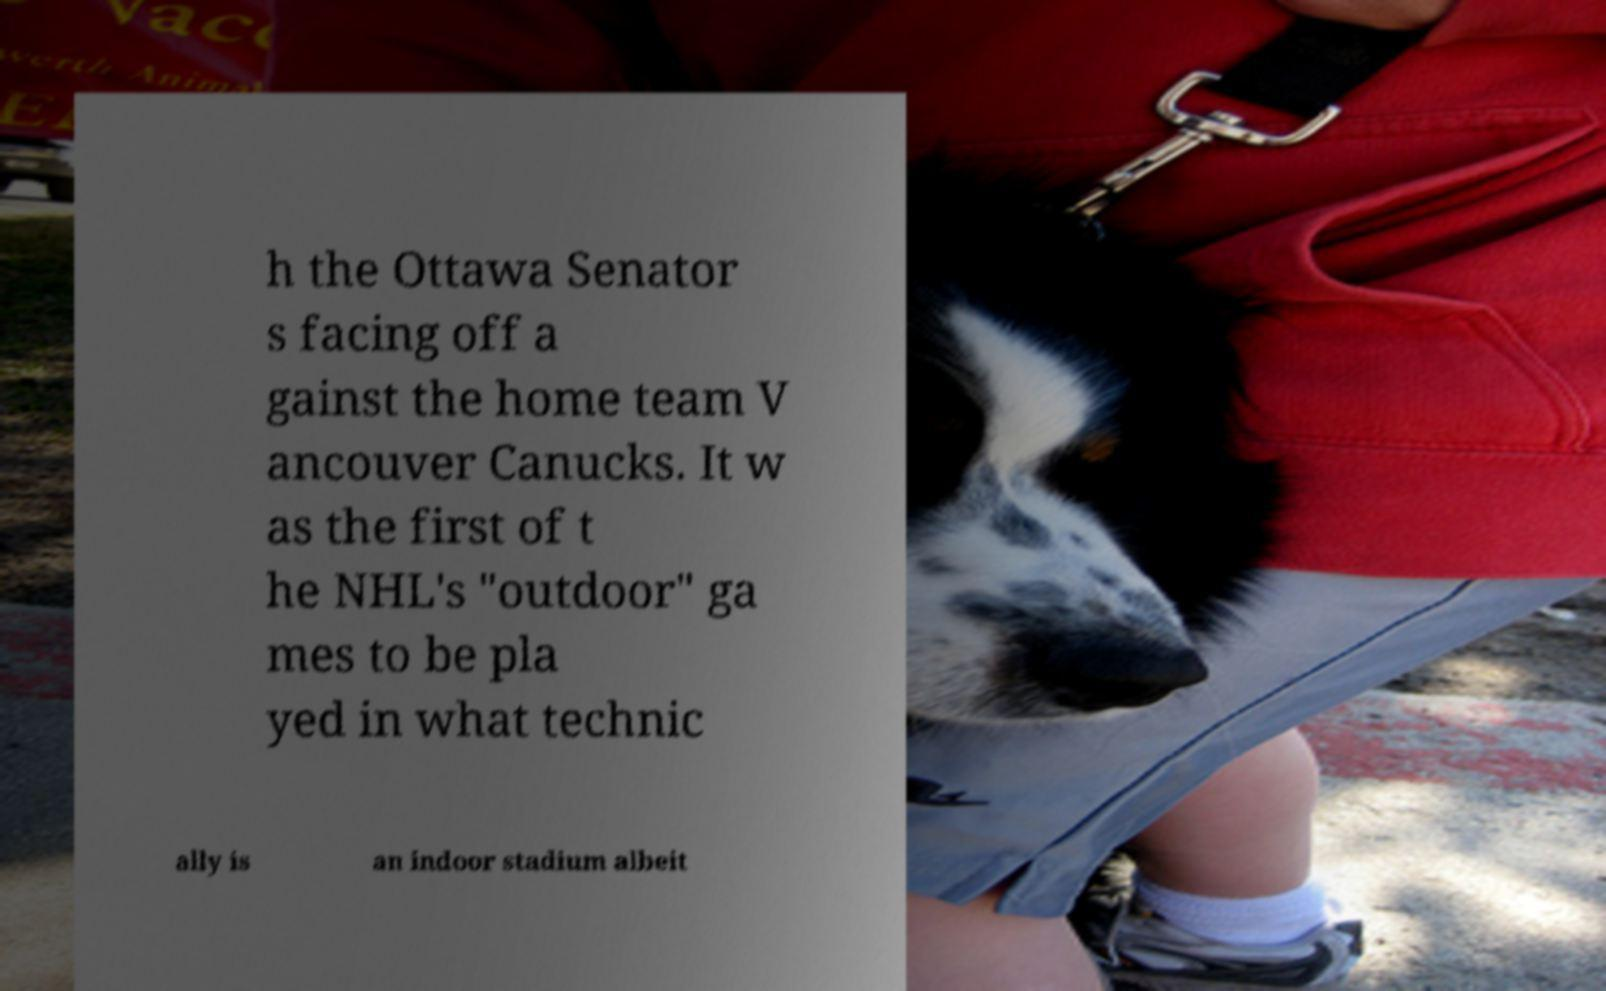There's text embedded in this image that I need extracted. Can you transcribe it verbatim? h the Ottawa Senator s facing off a gainst the home team V ancouver Canucks. It w as the first of t he NHL's "outdoor" ga mes to be pla yed in what technic ally is an indoor stadium albeit 